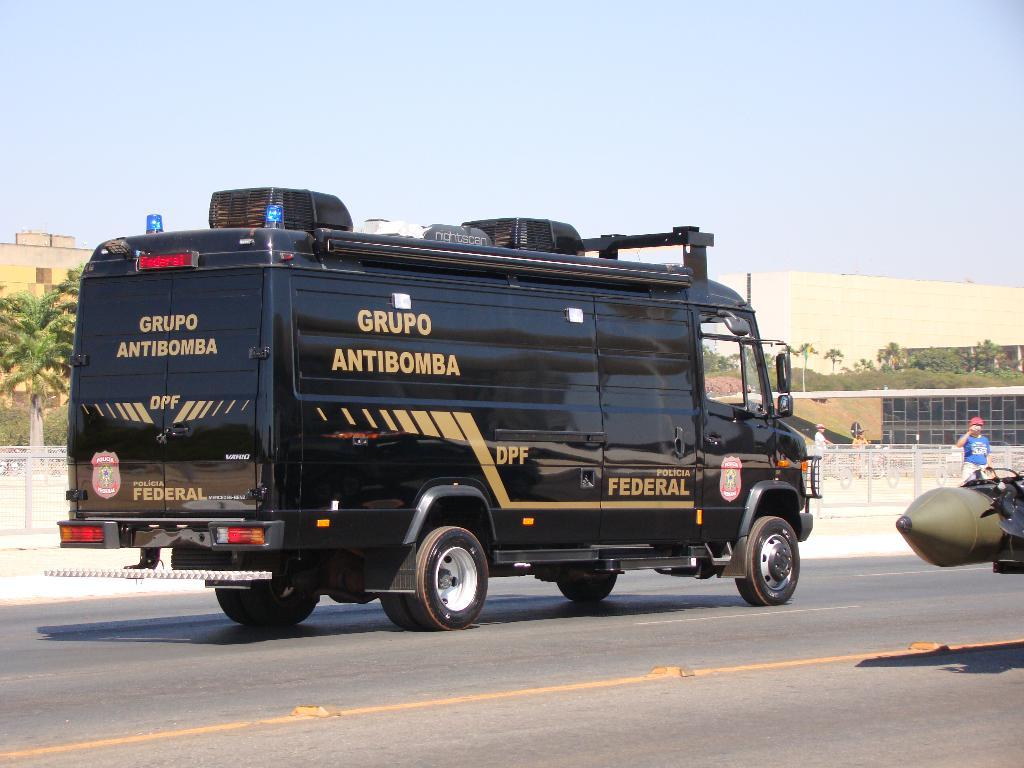Is this a federal vehicle?
Make the answer very short. Yes. What kind of truck is this?
Offer a terse response. Grupo antibomba. 